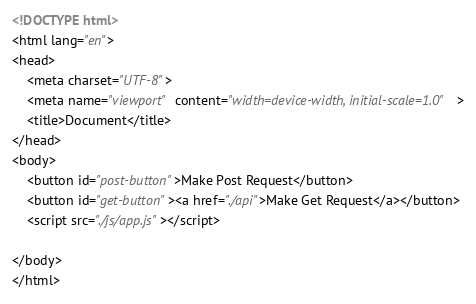<code> <loc_0><loc_0><loc_500><loc_500><_HTML_><!DOCTYPE html>
<html lang="en">
<head>
    <meta charset="UTF-8">
    <meta name="viewport" content="width=device-width, initial-scale=1.0">
    <title>Document</title>
</head>
<body>
    <button id="post-button">Make Post Request</button>
    <button id="get-button"><a href="./api">Make Get Request</a></button>
    <script src="./js/app.js"></script>
    
</body>
</html></code> 